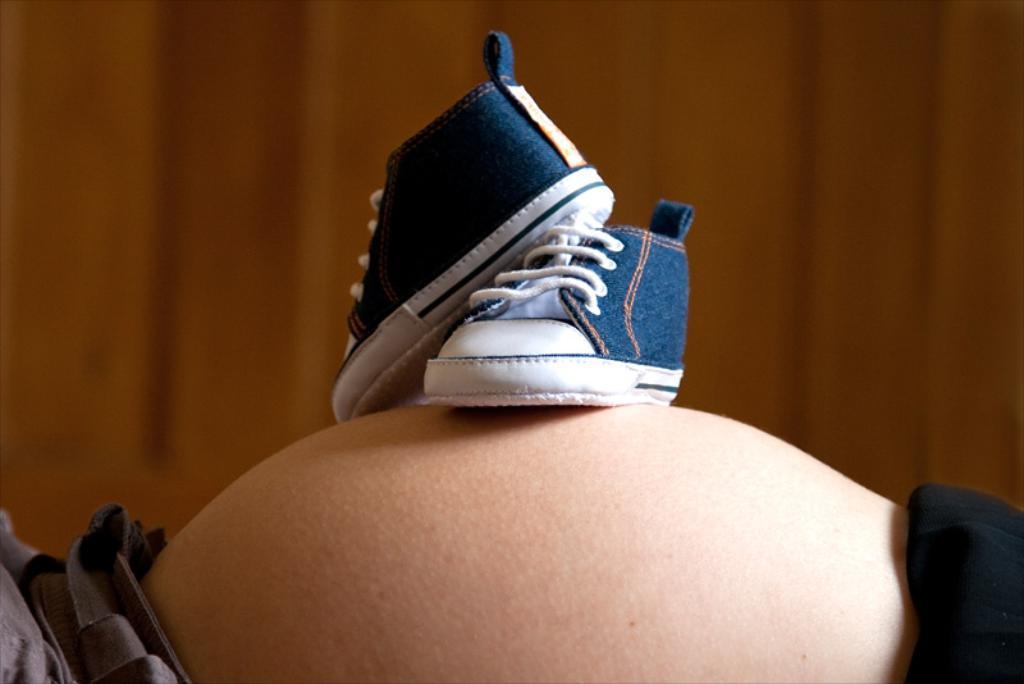In one or two sentences, can you explain what this image depicts? In this picture we can see a person stomach, on this stomach we can see shoes and in the background we can see a wall and it is blurry. 